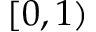Convert formula to latex. <formula><loc_0><loc_0><loc_500><loc_500>[ 0 , 1 )</formula> 